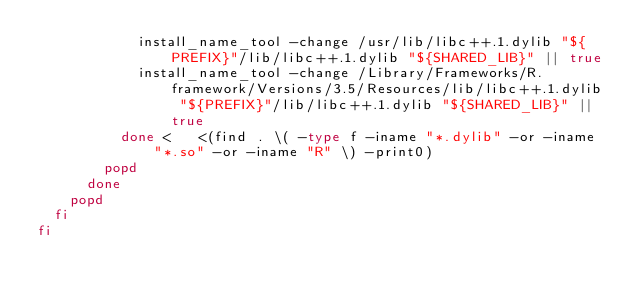<code> <loc_0><loc_0><loc_500><loc_500><_Bash_>            install_name_tool -change /usr/lib/libc++.1.dylib "${PREFIX}"/lib/libc++.1.dylib "${SHARED_LIB}" || true
            install_name_tool -change /Library/Frameworks/R.framework/Versions/3.5/Resources/lib/libc++.1.dylib "${PREFIX}"/lib/libc++.1.dylib "${SHARED_LIB}" || true
          done <   <(find . \( -type f -iname "*.dylib" -or -iname "*.so" -or -iname "R" \) -print0)
        popd
      done
    popd
  fi
fi
</code> 